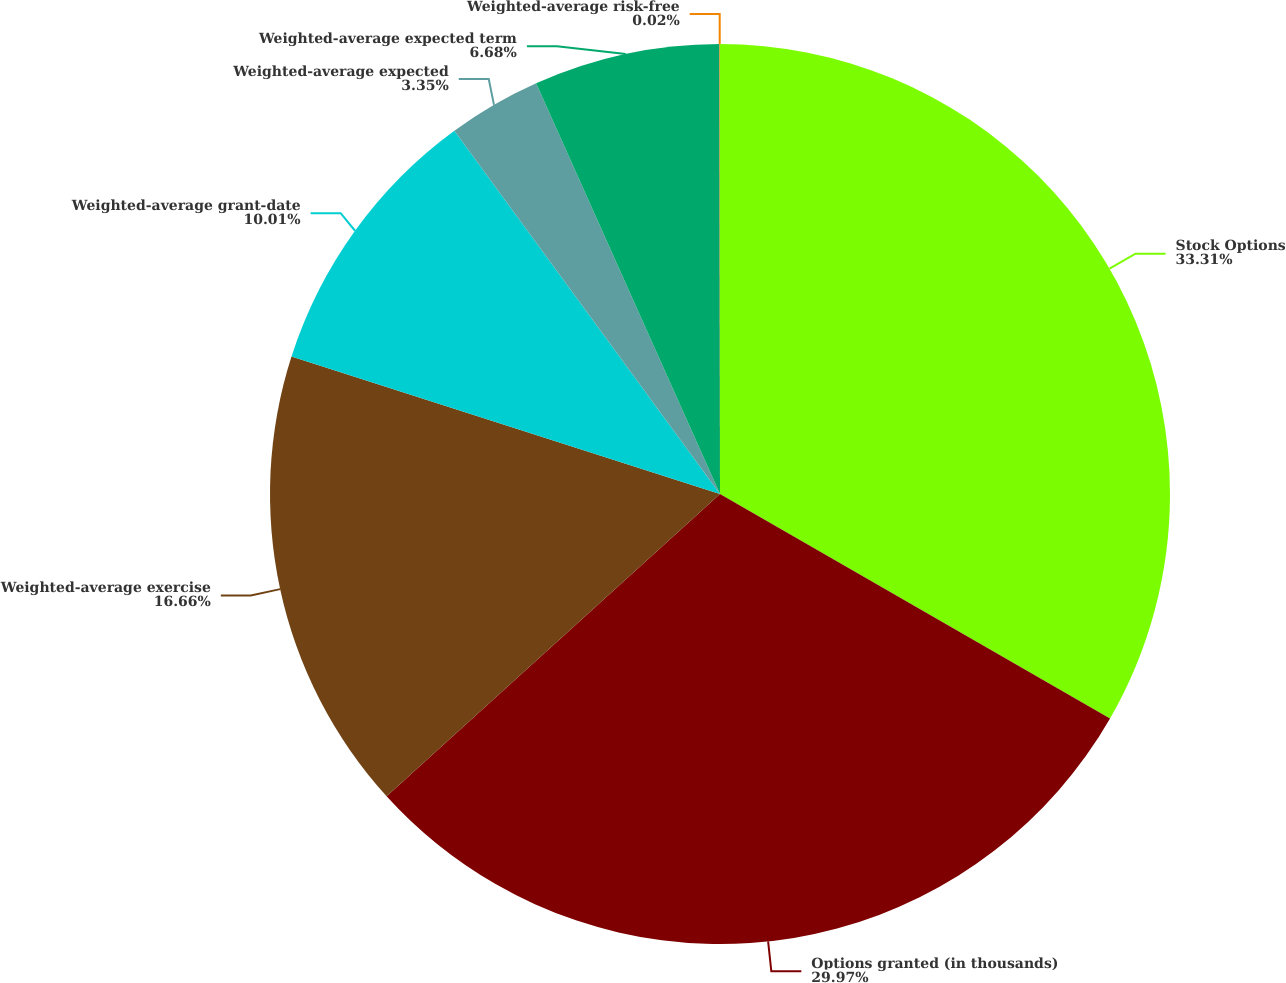<chart> <loc_0><loc_0><loc_500><loc_500><pie_chart><fcel>Stock Options<fcel>Options granted (in thousands)<fcel>Weighted-average exercise<fcel>Weighted-average grant-date<fcel>Weighted-average expected<fcel>Weighted-average expected term<fcel>Weighted-average risk-free<nl><fcel>33.31%<fcel>29.97%<fcel>16.66%<fcel>10.01%<fcel>3.35%<fcel>6.68%<fcel>0.02%<nl></chart> 